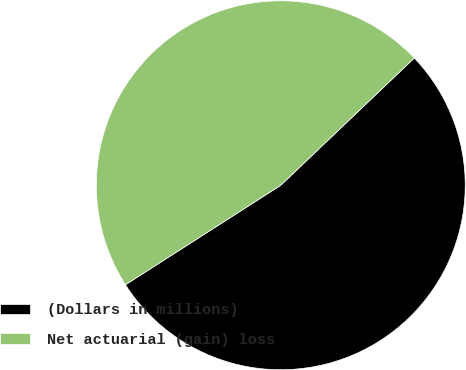<chart> <loc_0><loc_0><loc_500><loc_500><pie_chart><fcel>(Dollars in millions)<fcel>Net actuarial (gain) loss<nl><fcel>53.05%<fcel>46.95%<nl></chart> 